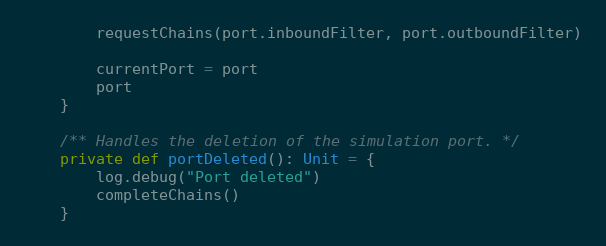Convert code to text. <code><loc_0><loc_0><loc_500><loc_500><_Scala_>        requestChains(port.inboundFilter, port.outboundFilter)

        currentPort = port
        port
    }

    /** Handles the deletion of the simulation port. */
    private def portDeleted(): Unit = {
        log.debug("Port deleted")
        completeChains()
    }
</code> 